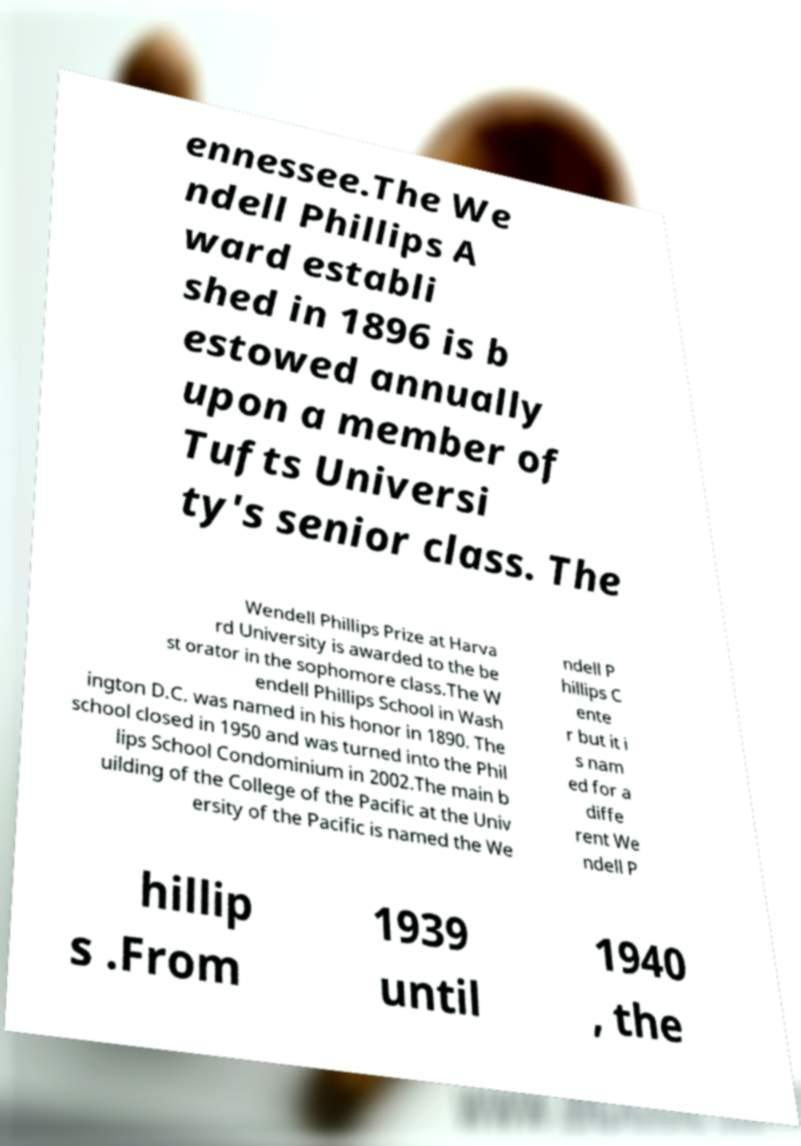Can you accurately transcribe the text from the provided image for me? ennessee.The We ndell Phillips A ward establi shed in 1896 is b estowed annually upon a member of Tufts Universi ty's senior class. The Wendell Phillips Prize at Harva rd University is awarded to the be st orator in the sophomore class.The W endell Phillips School in Wash ington D.C. was named in his honor in 1890. The school closed in 1950 and was turned into the Phil lips School Condominium in 2002.The main b uilding of the College of the Pacific at the Univ ersity of the Pacific is named the We ndell P hillips C ente r but it i s nam ed for a diffe rent We ndell P hillip s .From 1939 until 1940 , the 